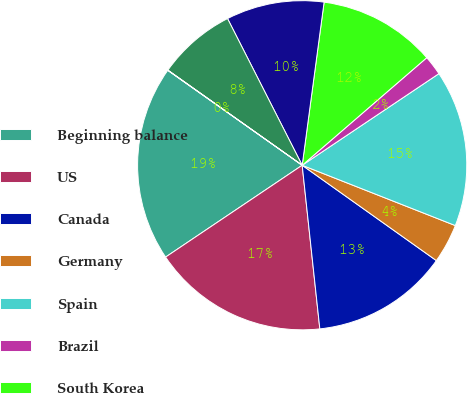Convert chart. <chart><loc_0><loc_0><loc_500><loc_500><pie_chart><fcel>Beginning balance<fcel>US<fcel>Canada<fcel>Germany<fcel>Spain<fcel>Brazil<fcel>South Korea<fcel>Australia<fcel>UK<fcel>Sweden<nl><fcel>19.21%<fcel>17.29%<fcel>13.46%<fcel>3.86%<fcel>15.37%<fcel>1.94%<fcel>11.54%<fcel>9.62%<fcel>7.7%<fcel>0.02%<nl></chart> 